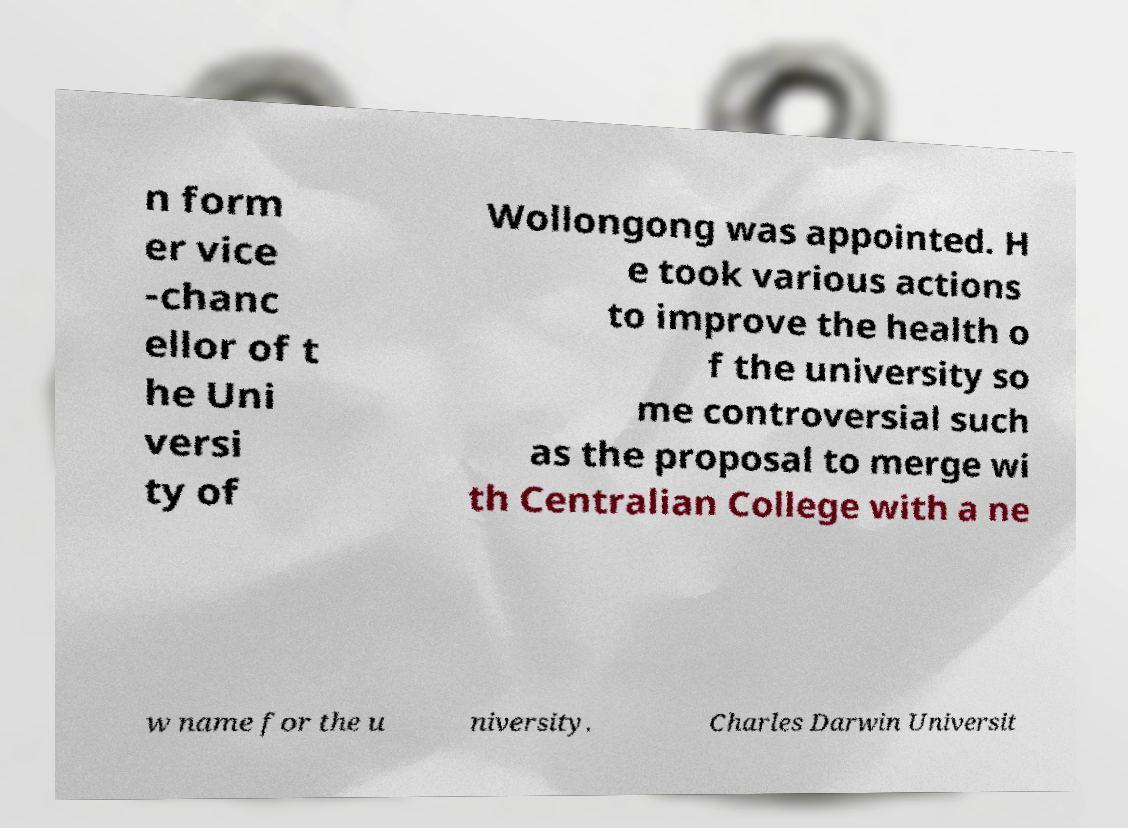Can you read and provide the text displayed in the image?This photo seems to have some interesting text. Can you extract and type it out for me? n form er vice -chanc ellor of t he Uni versi ty of Wollongong was appointed. H e took various actions to improve the health o f the university so me controversial such as the proposal to merge wi th Centralian College with a ne w name for the u niversity. Charles Darwin Universit 